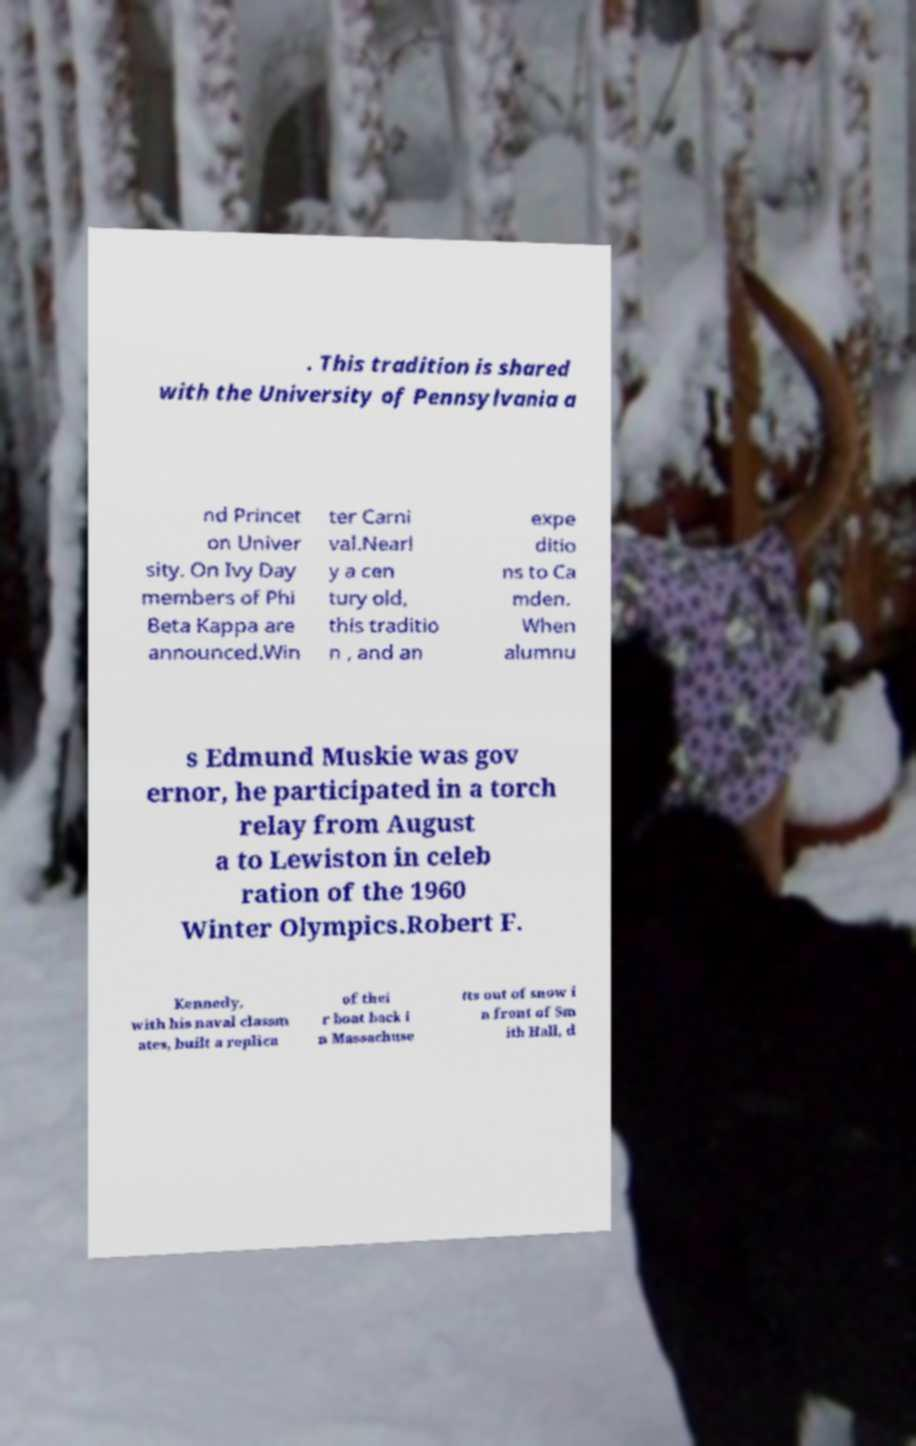There's text embedded in this image that I need extracted. Can you transcribe it verbatim? . This tradition is shared with the University of Pennsylvania a nd Princet on Univer sity. On Ivy Day members of Phi Beta Kappa are announced.Win ter Carni val.Nearl y a cen tury old, this traditio n , and an expe ditio ns to Ca mden. When alumnu s Edmund Muskie was gov ernor, he participated in a torch relay from August a to Lewiston in celeb ration of the 1960 Winter Olympics.Robert F. Kennedy, with his naval classm ates, built a replica of thei r boat back i n Massachuse tts out of snow i n front of Sm ith Hall, d 